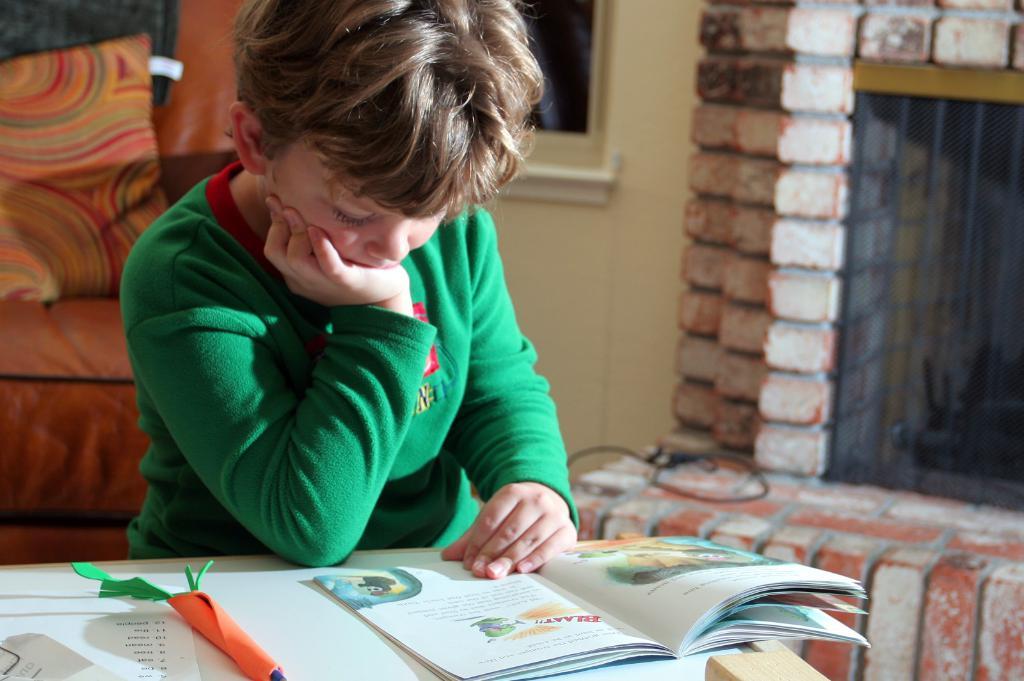What word is on the page of hte book?
Keep it short and to the point. Unanswerable. 